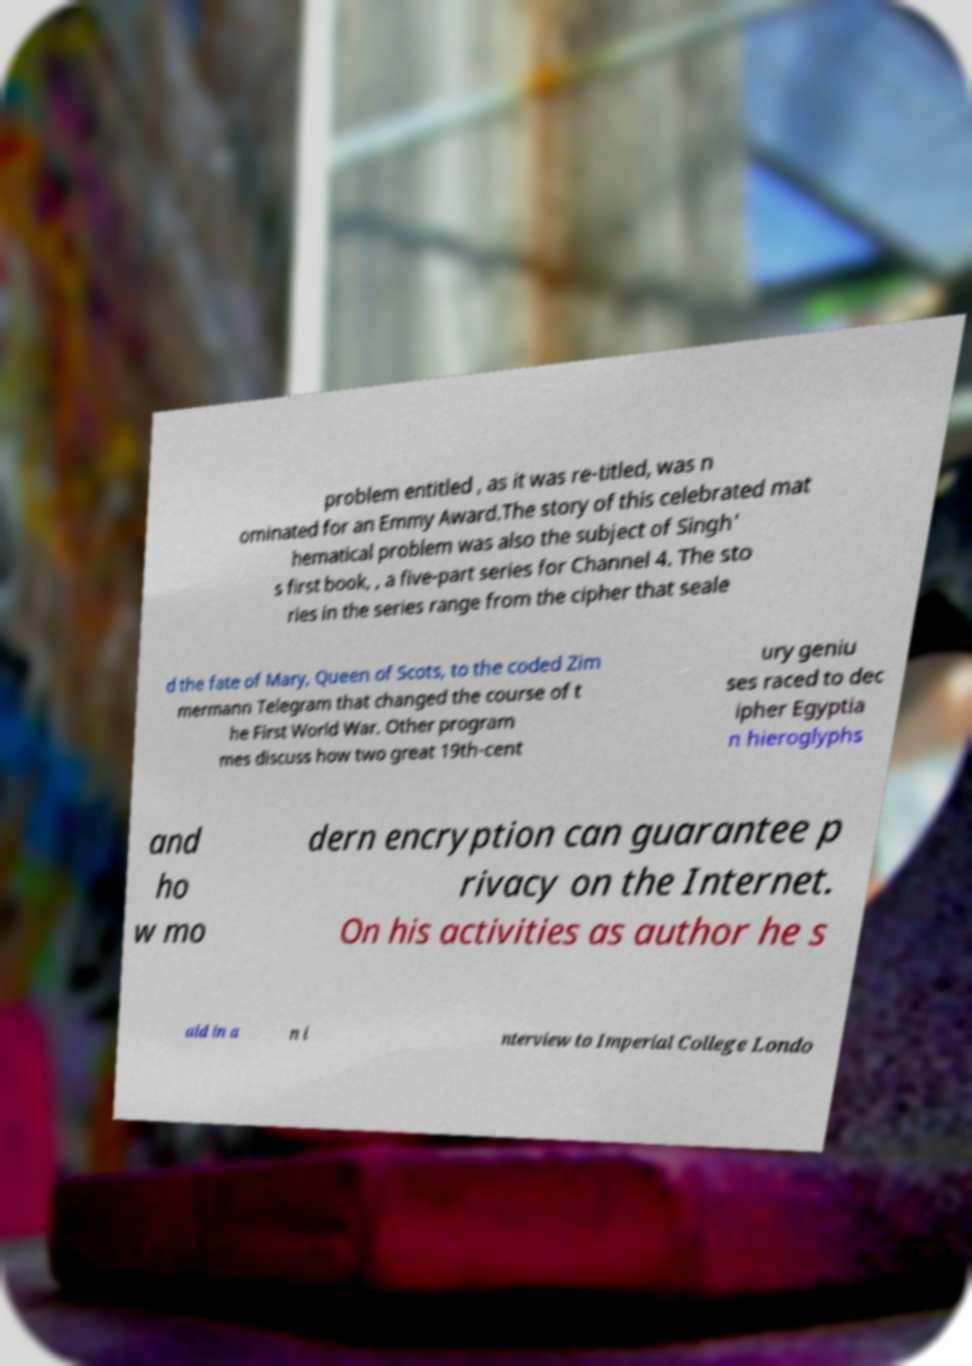What messages or text are displayed in this image? I need them in a readable, typed format. problem entitled , as it was re-titled, was n ominated for an Emmy Award.The story of this celebrated mat hematical problem was also the subject of Singh' s first book, , a five-part series for Channel 4. The sto ries in the series range from the cipher that seale d the fate of Mary, Queen of Scots, to the coded Zim mermann Telegram that changed the course of t he First World War. Other program mes discuss how two great 19th-cent ury geniu ses raced to dec ipher Egyptia n hieroglyphs and ho w mo dern encryption can guarantee p rivacy on the Internet. On his activities as author he s aid in a n i nterview to Imperial College Londo 